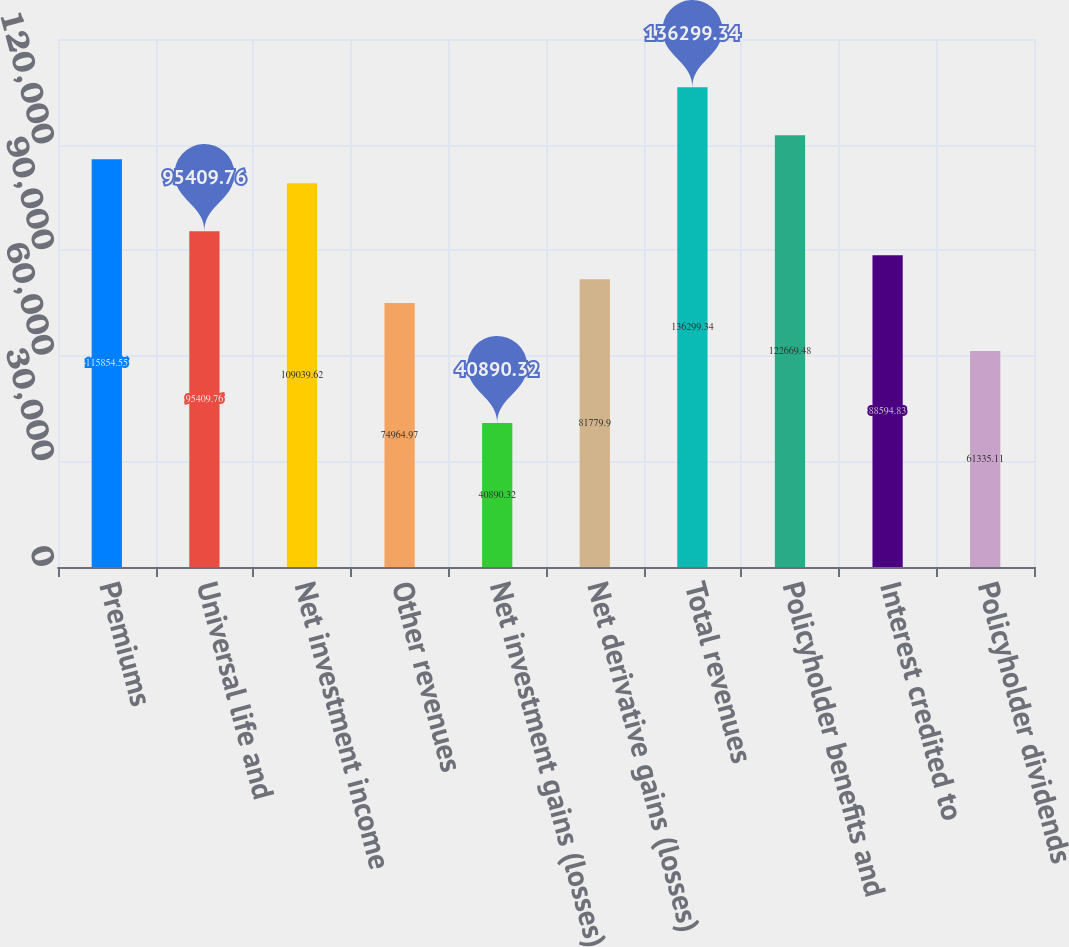<chart> <loc_0><loc_0><loc_500><loc_500><bar_chart><fcel>Premiums<fcel>Universal life and<fcel>Net investment income<fcel>Other revenues<fcel>Net investment gains (losses)<fcel>Net derivative gains (losses)<fcel>Total revenues<fcel>Policyholder benefits and<fcel>Interest credited to<fcel>Policyholder dividends<nl><fcel>115855<fcel>95409.8<fcel>109040<fcel>74965<fcel>40890.3<fcel>81779.9<fcel>136299<fcel>122669<fcel>88594.8<fcel>61335.1<nl></chart> 